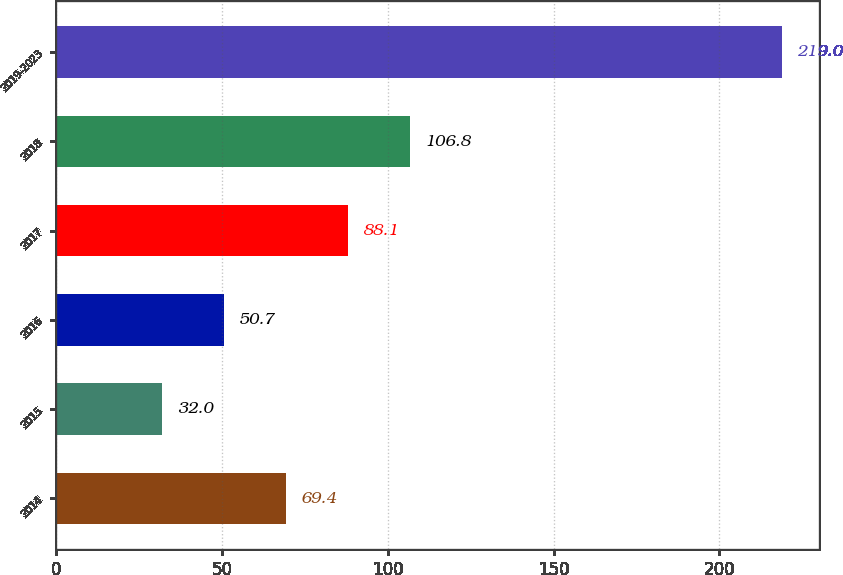<chart> <loc_0><loc_0><loc_500><loc_500><bar_chart><fcel>2014<fcel>2015<fcel>2016<fcel>2017<fcel>2018<fcel>2019-2023<nl><fcel>69.4<fcel>32<fcel>50.7<fcel>88.1<fcel>106.8<fcel>219<nl></chart> 